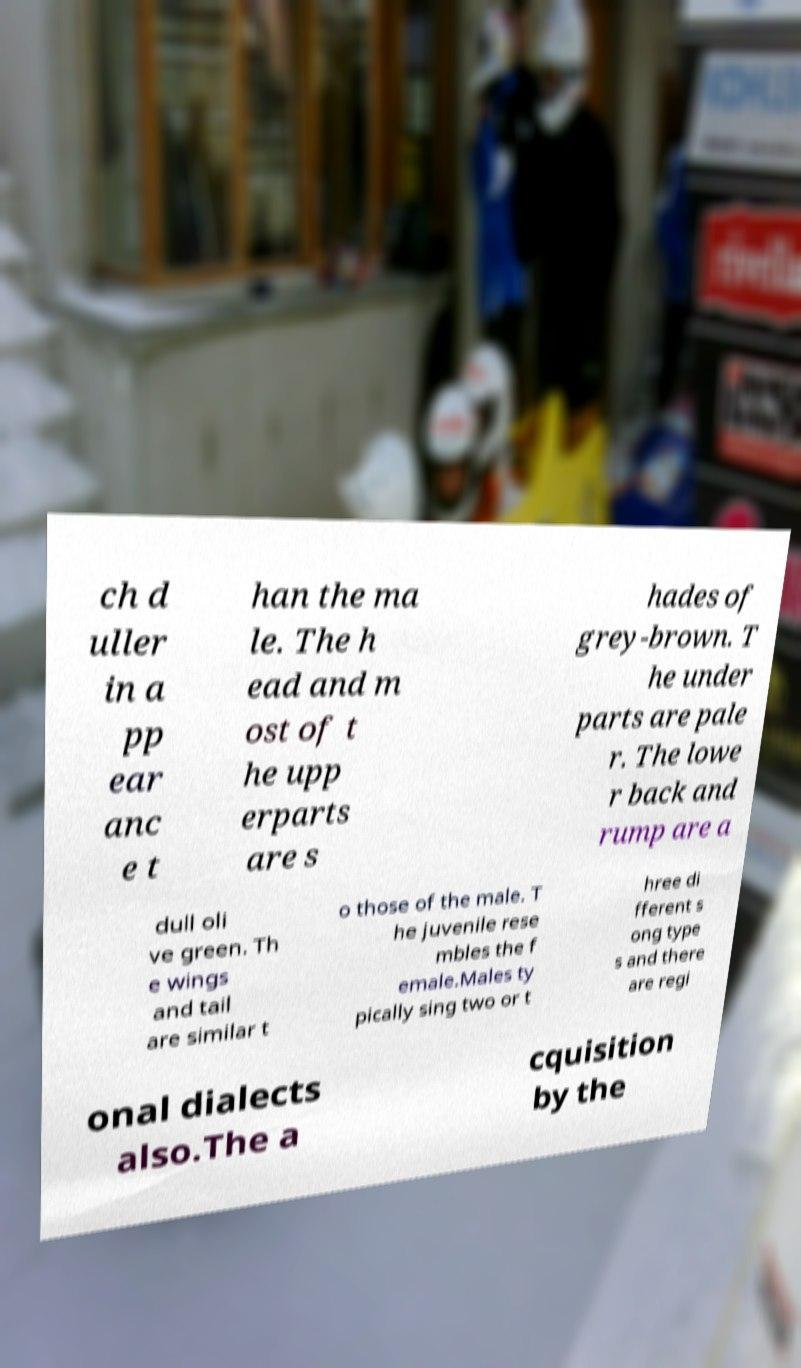Please identify and transcribe the text found in this image. ch d uller in a pp ear anc e t han the ma le. The h ead and m ost of t he upp erparts are s hades of grey-brown. T he under parts are pale r. The lowe r back and rump are a dull oli ve green. Th e wings and tail are similar t o those of the male. T he juvenile rese mbles the f emale.Males ty pically sing two or t hree di fferent s ong type s and there are regi onal dialects also.The a cquisition by the 